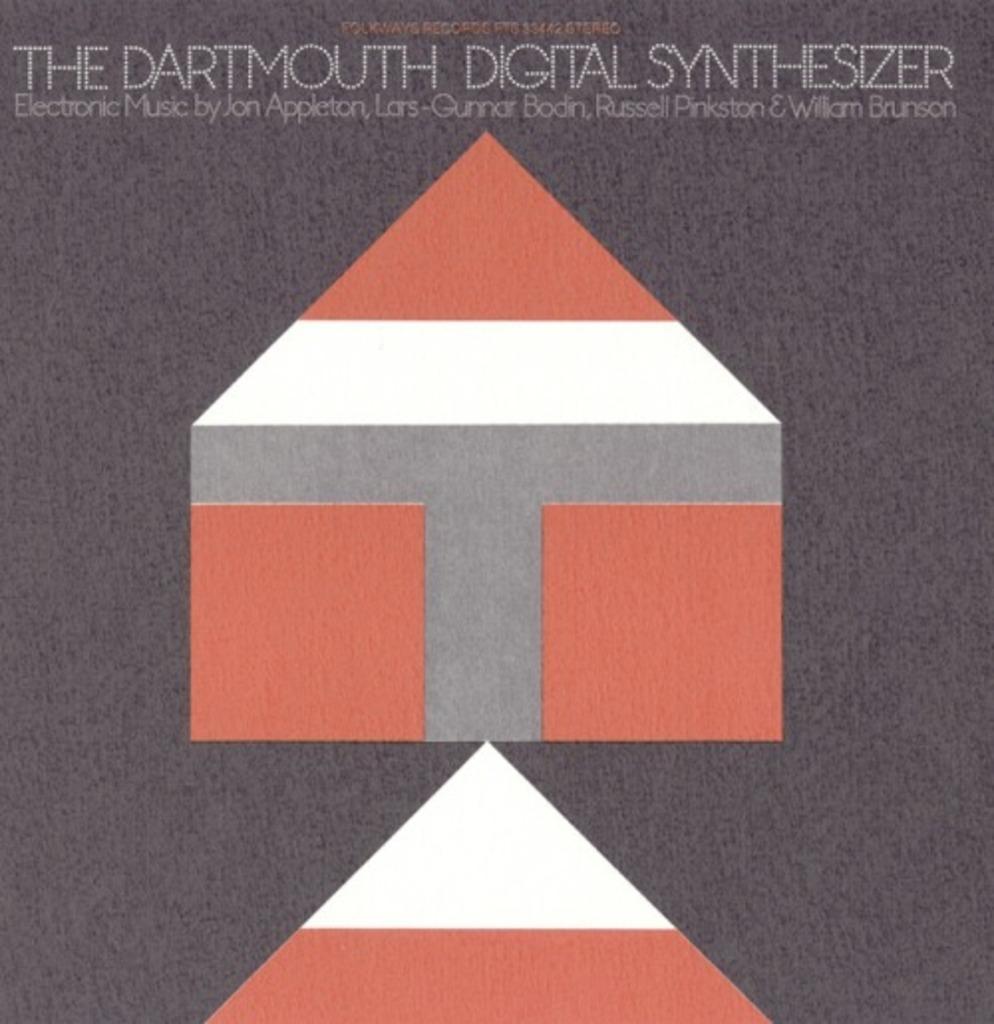What kind of synthesizer is this?
Your response must be concise. Digital. Who are some of the people making music?
Provide a succinct answer. Job appleton, lars-qunnar bodin, russel pinkston, . 